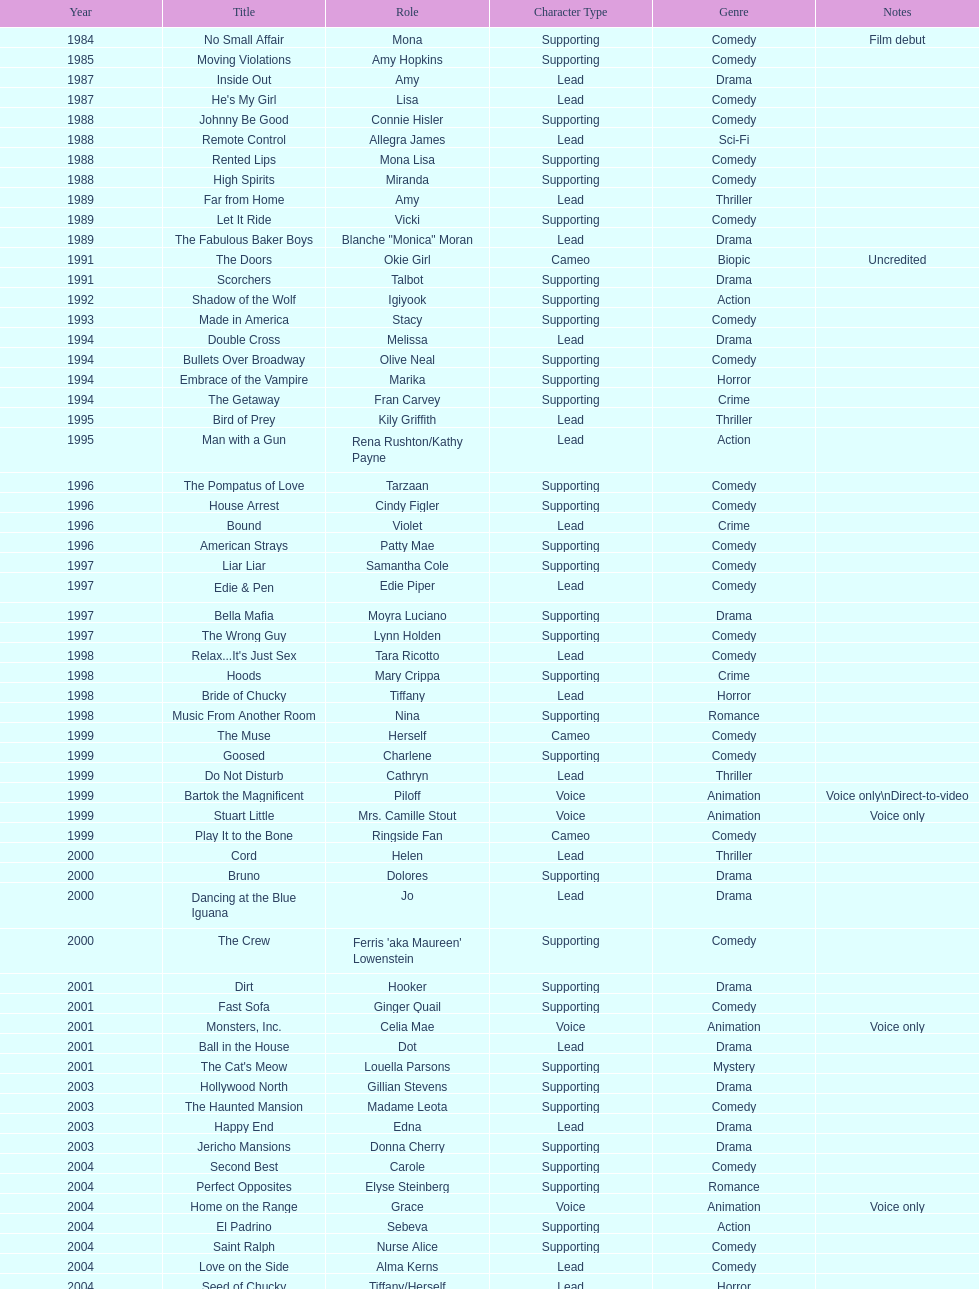Which film has their role under igiyook? Shadow of the Wolf. 